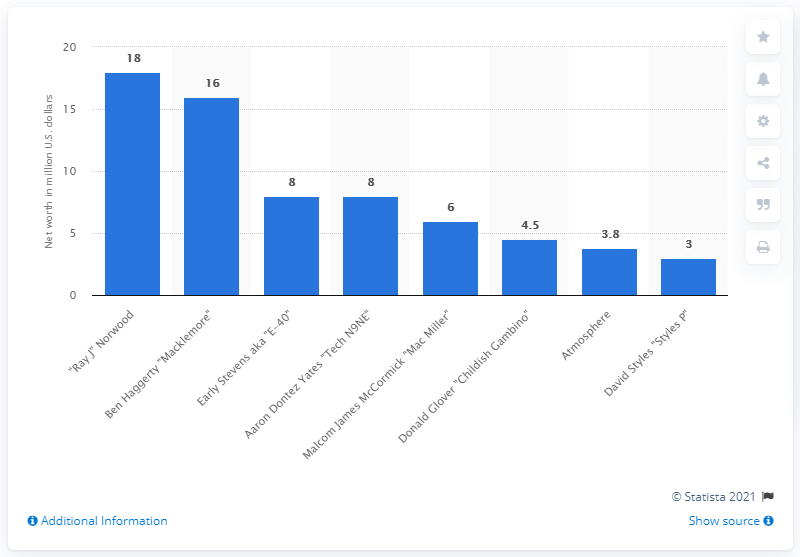Highlight a few significant elements in this photo. Ben Haggerty's estimated net worth was estimated to be approximately 16 million dollars. 